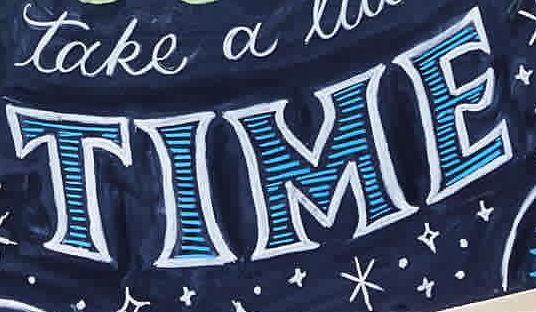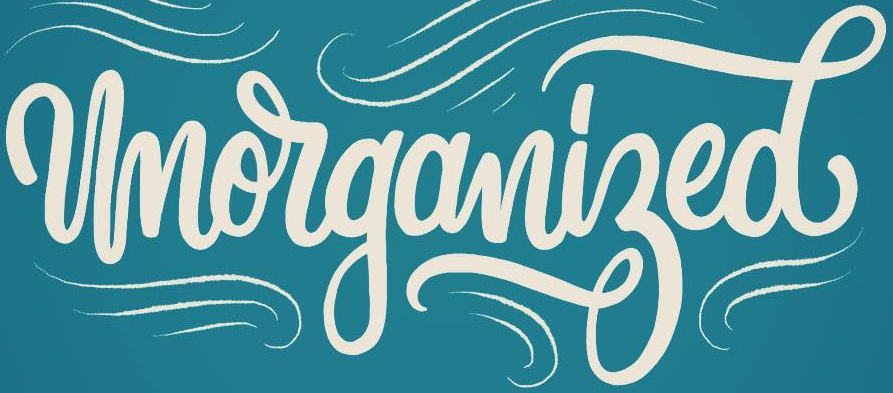What text is displayed in these images sequentially, separated by a semicolon? TIME; Unorganized 